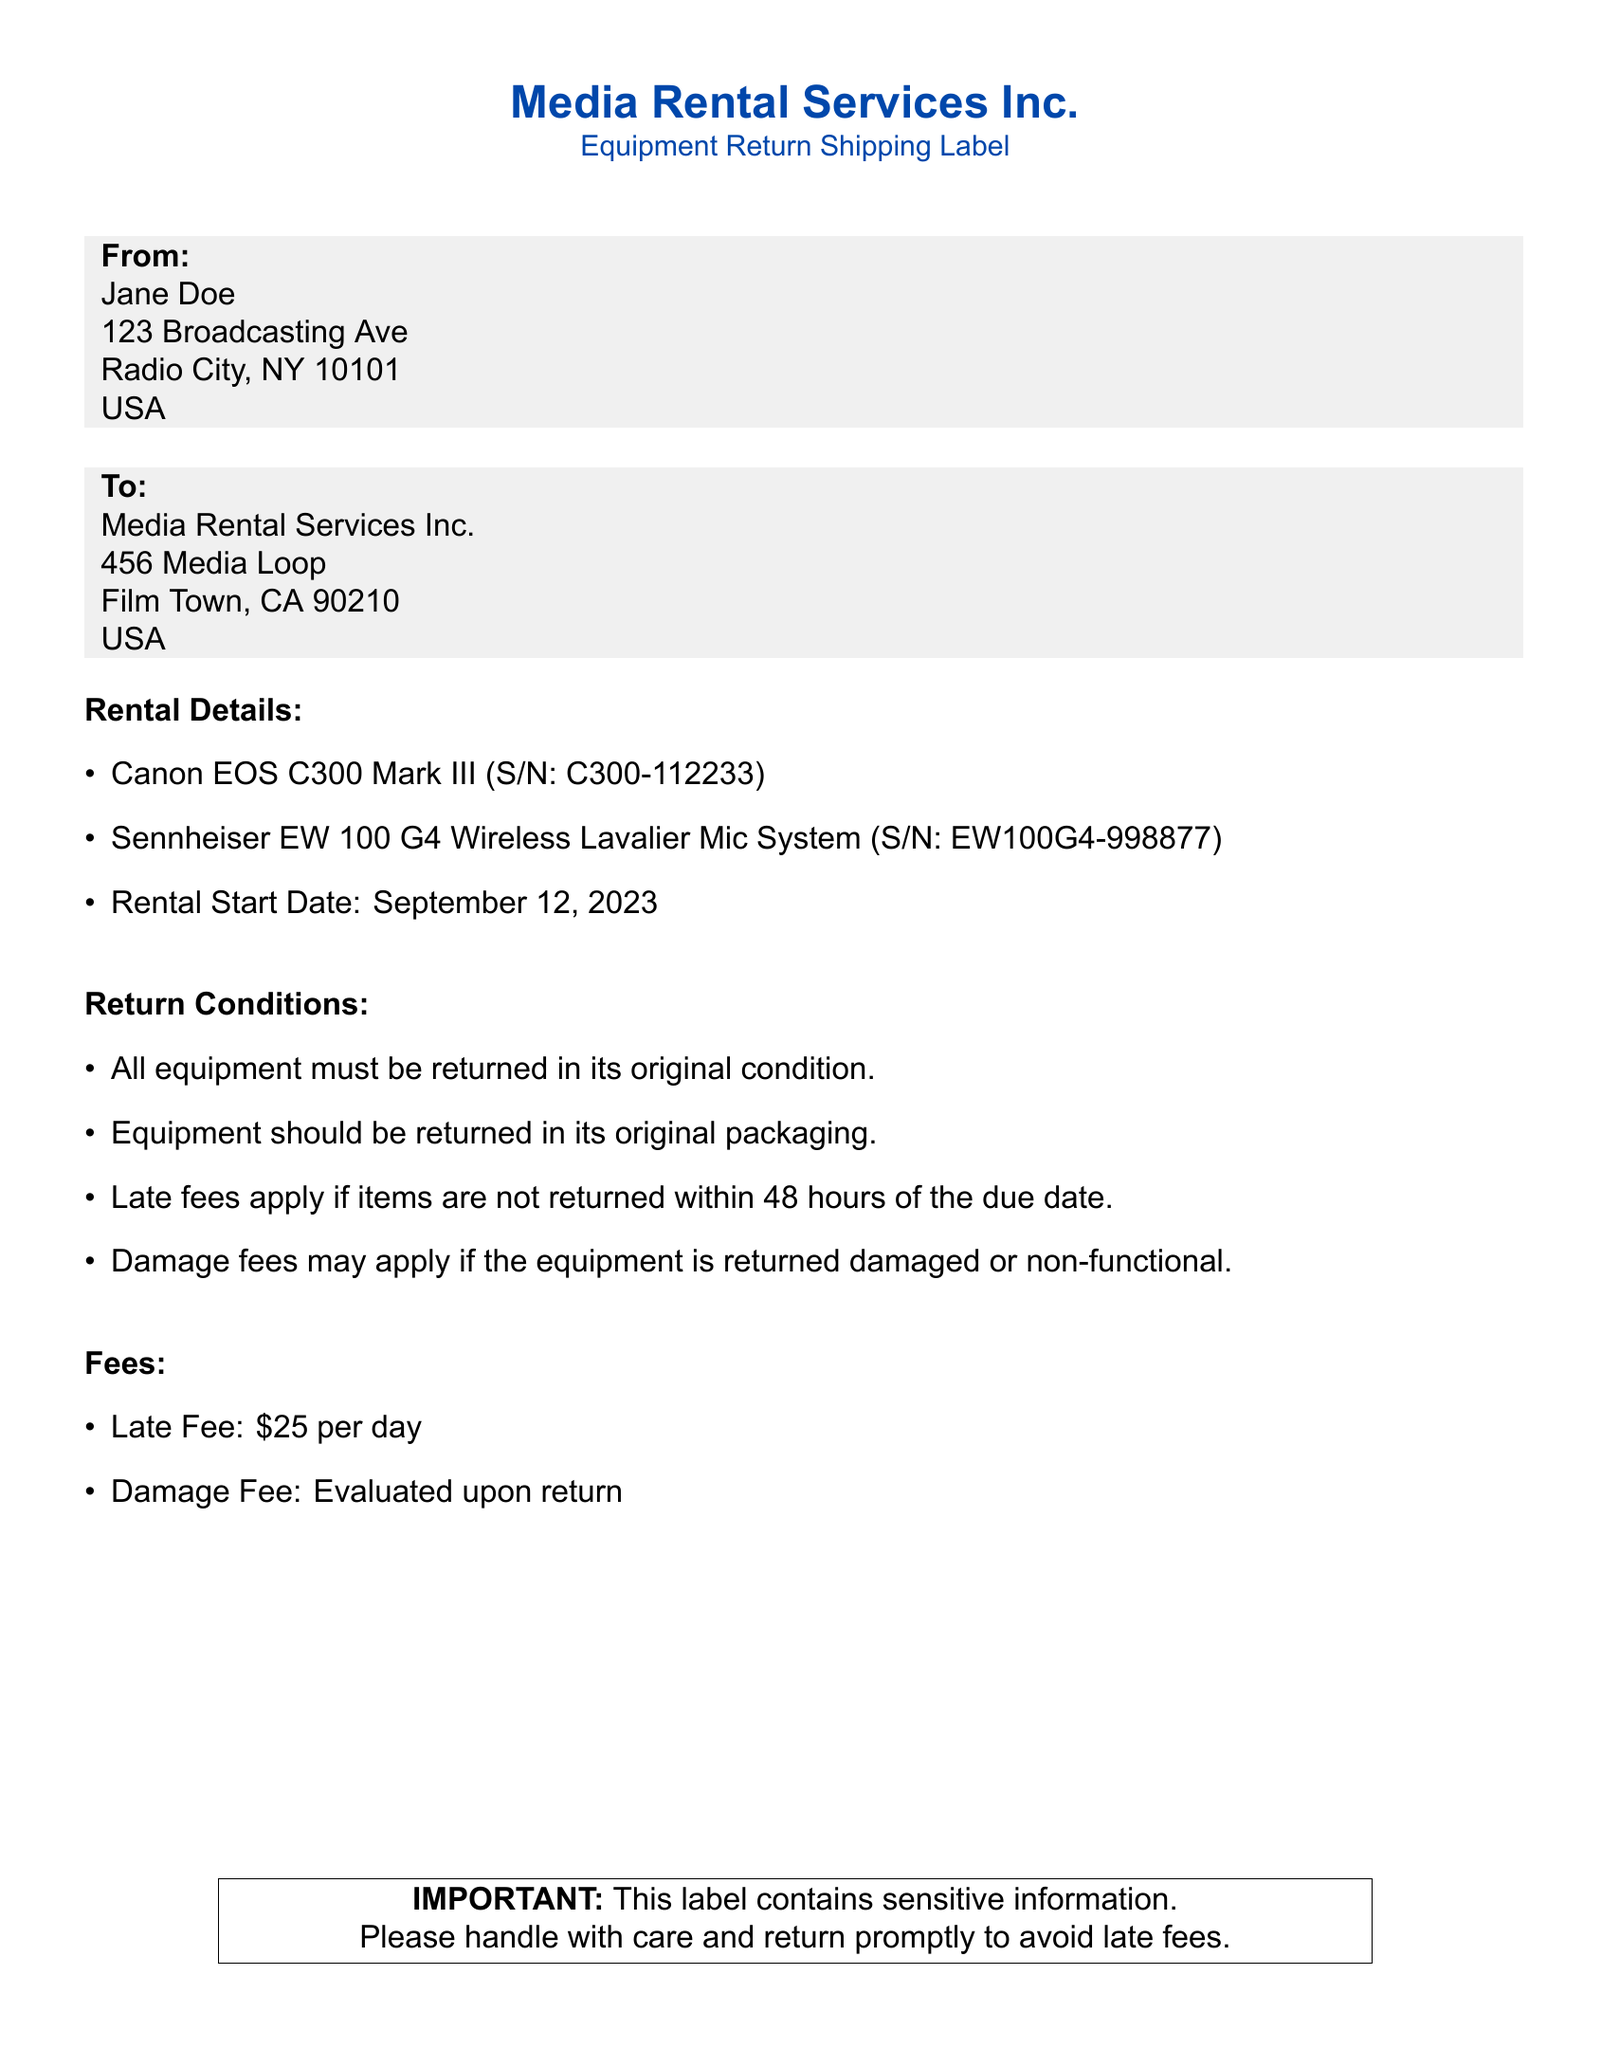what is the sender's name? The sender is identified at the top of the shipping label, where it states "From: Jane Doe."
Answer: Jane Doe what are the items being returned? The items are listed under the "Rental Details" section, which includes the specific equipment and their serial numbers.
Answer: Canon EOS C300 Mark III, Sennheiser EW 100 G4 Wireless Lavalier Mic System when is the rental start date? The rental start date is mentioned under "Rental Details," providing a specific date of rental initiation.
Answer: September 12, 2023 what is the late fee cost per day? The late fee is specified in the "Fees" section of the document, detailing the cost incurred for overdue items.
Answer: $25 what condition must the equipment be returned in? The return conditions state that all equipment must be returned in its original condition, emphasizing the importance of the equipment's state upon return.
Answer: Original condition how long do you have to return the equipment to avoid late fees? The document specifies a time frame of 48 hours to return the equipment to avoid incurring additional fees.
Answer: 48 hours where should the equipment be sent back to? The recipient address is outlined in the "To:" section of the document, providing a specific location for returns.
Answer: Media Rental Services Inc., 456 Media Loop, Film Town, CA 90210 what are the damage fees based on? The document indicates that damage fees are evaluated upon return, meaning they are determined at that time.
Answer: Evaluated upon return what is the original packaging requirement? The return conditions state that equipment should be returned in its original packaging, highlighting the importance of preserving the packaging.
Answer: Original packaging 